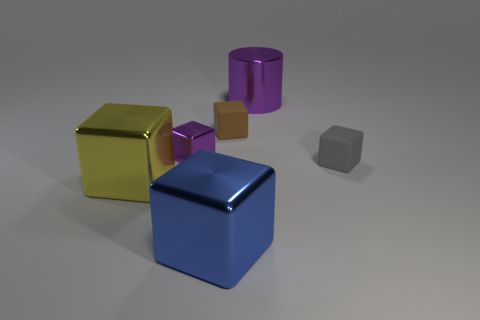How many objects are both behind the gray block and to the left of the purple shiny cylinder?
Provide a short and direct response. 2. What number of other objects are the same material as the yellow block?
Give a very brief answer. 3. What color is the tiny matte cube to the left of the gray rubber block that is on the right side of the big purple shiny thing?
Provide a short and direct response. Brown. Does the rubber cube in front of the brown rubber block have the same color as the big cylinder?
Ensure brevity in your answer.  No. Do the yellow object and the blue block have the same size?
Make the answer very short. Yes. What is the shape of the yellow metal thing that is the same size as the blue shiny cube?
Your response must be concise. Cube. There is a rubber block in front of the brown rubber block; does it have the same size as the tiny purple block?
Keep it short and to the point. Yes. There is a yellow cube that is the same size as the blue metallic block; what material is it?
Your answer should be very brief. Metal. Is there a big purple cylinder to the left of the metallic thing right of the matte cube that is to the left of the cylinder?
Provide a succinct answer. No. Is there any other thing that has the same shape as the blue thing?
Provide a short and direct response. Yes. 